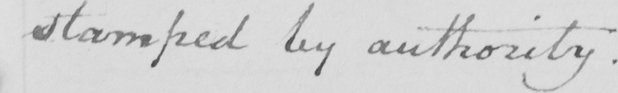Can you tell me what this handwritten text says? stamped by authority. 